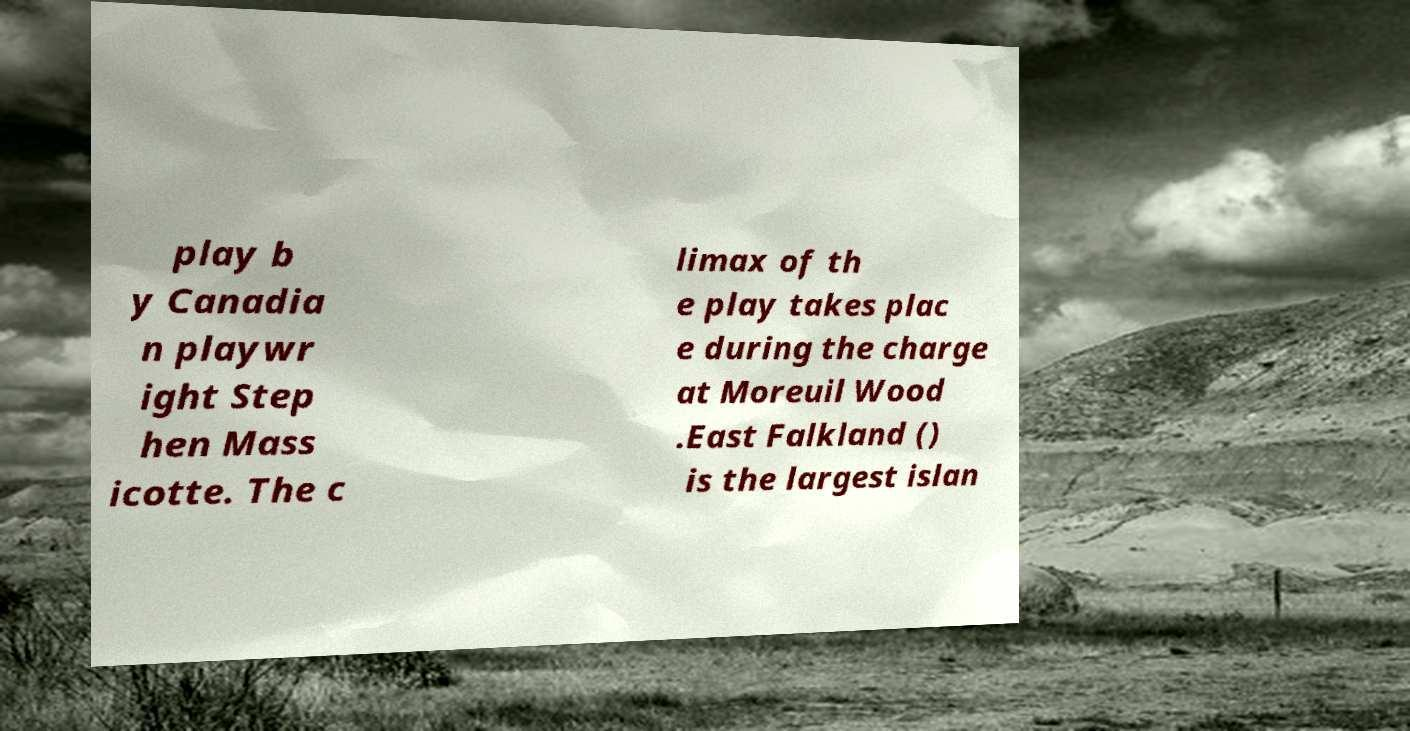I need the written content from this picture converted into text. Can you do that? play b y Canadia n playwr ight Step hen Mass icotte. The c limax of th e play takes plac e during the charge at Moreuil Wood .East Falkland () is the largest islan 